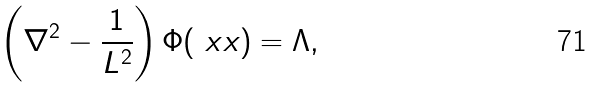<formula> <loc_0><loc_0><loc_500><loc_500>\left ( \nabla ^ { 2 } - \frac { 1 } { L ^ { 2 } } \right ) \Phi ( \ x x ) = \Lambda ,</formula> 